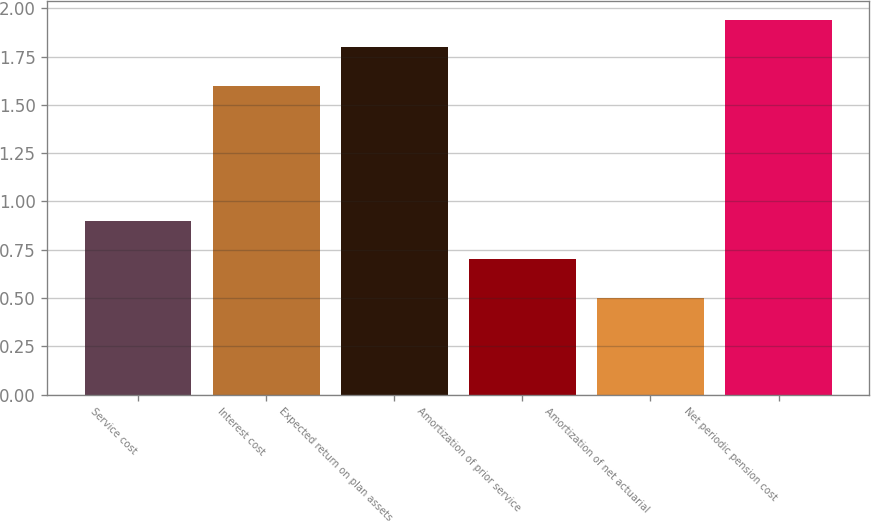Convert chart to OTSL. <chart><loc_0><loc_0><loc_500><loc_500><bar_chart><fcel>Service cost<fcel>Interest cost<fcel>Expected return on plan assets<fcel>Amortization of prior service<fcel>Amortization of net actuarial<fcel>Net periodic pension cost<nl><fcel>0.9<fcel>1.6<fcel>1.8<fcel>0.7<fcel>0.5<fcel>1.94<nl></chart> 